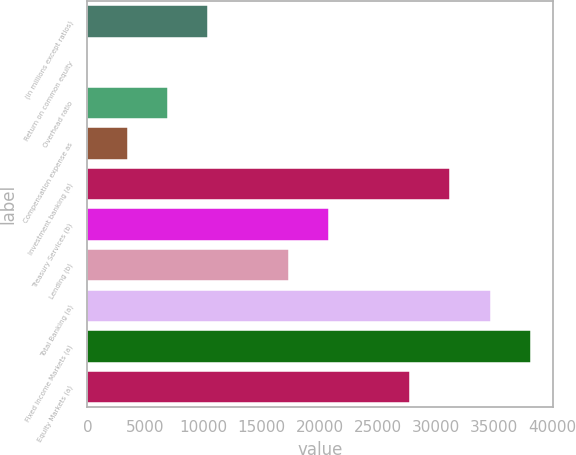<chart> <loc_0><loc_0><loc_500><loc_500><bar_chart><fcel>(in millions except ratios)<fcel>Return on common equity<fcel>Overhead ratio<fcel>Compensation expense as<fcel>Investment banking (a)<fcel>Treasury Services (b)<fcel>Lending (b)<fcel>Total Banking (a)<fcel>Fixed Income Markets (a)<fcel>Equity Markets (a)<nl><fcel>10424.1<fcel>15<fcel>6954.4<fcel>3484.7<fcel>31242.3<fcel>20833.2<fcel>17363.5<fcel>34712<fcel>38181.7<fcel>27772.6<nl></chart> 